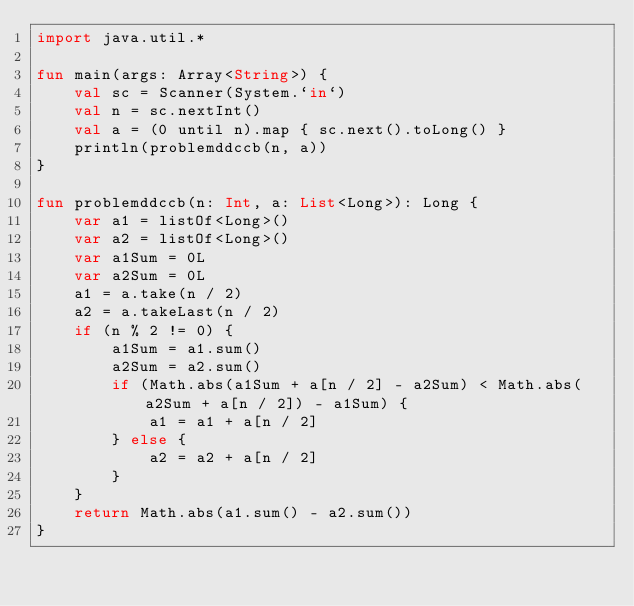<code> <loc_0><loc_0><loc_500><loc_500><_Kotlin_>import java.util.*

fun main(args: Array<String>) {
    val sc = Scanner(System.`in`)
    val n = sc.nextInt()
    val a = (0 until n).map { sc.next().toLong() }
    println(problemddccb(n, a))
}

fun problemddccb(n: Int, a: List<Long>): Long {
    var a1 = listOf<Long>()
    var a2 = listOf<Long>()
    var a1Sum = 0L
    var a2Sum = 0L
    a1 = a.take(n / 2)
    a2 = a.takeLast(n / 2)
    if (n % 2 != 0) {
        a1Sum = a1.sum()
        a2Sum = a2.sum()
        if (Math.abs(a1Sum + a[n / 2] - a2Sum) < Math.abs(a2Sum + a[n / 2]) - a1Sum) {
            a1 = a1 + a[n / 2]
        } else {
            a2 = a2 + a[n / 2]
        }
    }
    return Math.abs(a1.sum() - a2.sum())
}</code> 